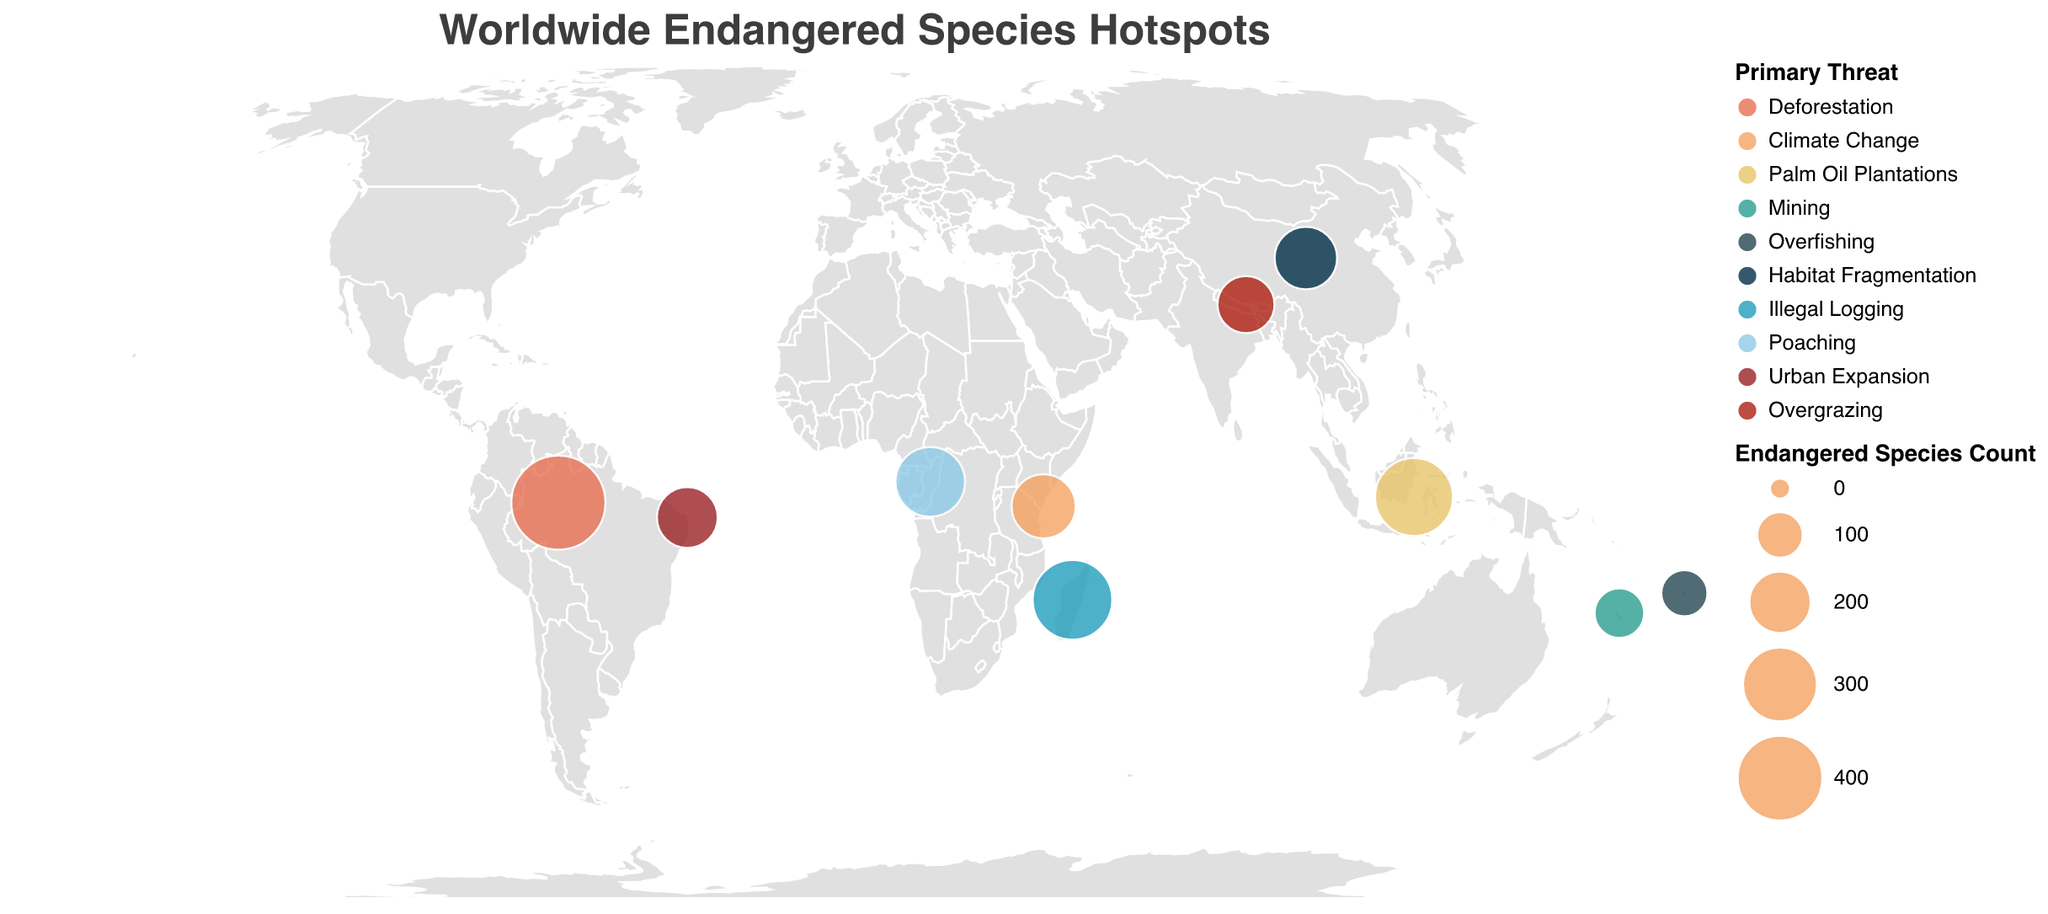What is the title of the plot? The title is displayed at the top of the plot in larger text and reads "Worldwide Endangered Species Hotspots."
Answer: Worldwide Endangered Species Hotspots What is the primary threat to species in the Amazon Rainforest? The Amazon Rainforest entry shows that the primary threat listed is "Deforestation"
Answer: Deforestation Which location has the highest count of endangered species? Among the locations, the Amazon Rainforest has the largest circle size, indicating the highest count of endangered species with 487.
Answer: Amazon Rainforest How many locations have poaching as the primary threat to endangered species? By looking at the legend and corresponding colors on the map, only the Congo Basin has "Poaching" as the primary threat.
Answer: 1 Which location has fewer endangered species: Borneo or Southwest China? Comparing the sizes of the circles representing these locations, we see that Southwest China (201) has fewer endangered species than Borneo (326).
Answer: Southwest China What is the range of endangered species count represented by different circle sizes? The legend indicates the range of circle sizes, which is from 100 to 2000 based on the count of endangered species.
Answer: 100 to 2000 Which threat has the highest diversity in affected locations? Count the distinct categories of "Primary Threat" across the various locations. The threats with most categories represented across different locations include "Deforestation," "Climate Change," and others.
Answer: Multiple including Deforestation, Climate Change What is the average count of endangered species across all mapped locations? Add the counts of endangered species from all locations and divide by the number of locations: (487 + 213 + 326 + 117 + 98 + 201 + 342 + 256 + 189 + 163) / 10 = 2392 / 10
Answer: 239.2 Which location faces "Urban Expansion" as the primary threat, and how many endangered species are there? The legend and circle size corresponding to the Atlantic Forest indicate "Urban Expansion" with 189 endangered species.
Answer: Atlantic Forest, 189 How do the threats to endangered species differ between Madagascar and Congo Basin? Madagascar's primary threat is “Illegal Logging” while Congo Basin’s is “Poaching,” per the figure’s color and legend association.
Answer: Illegal Logging vs. Poaching 